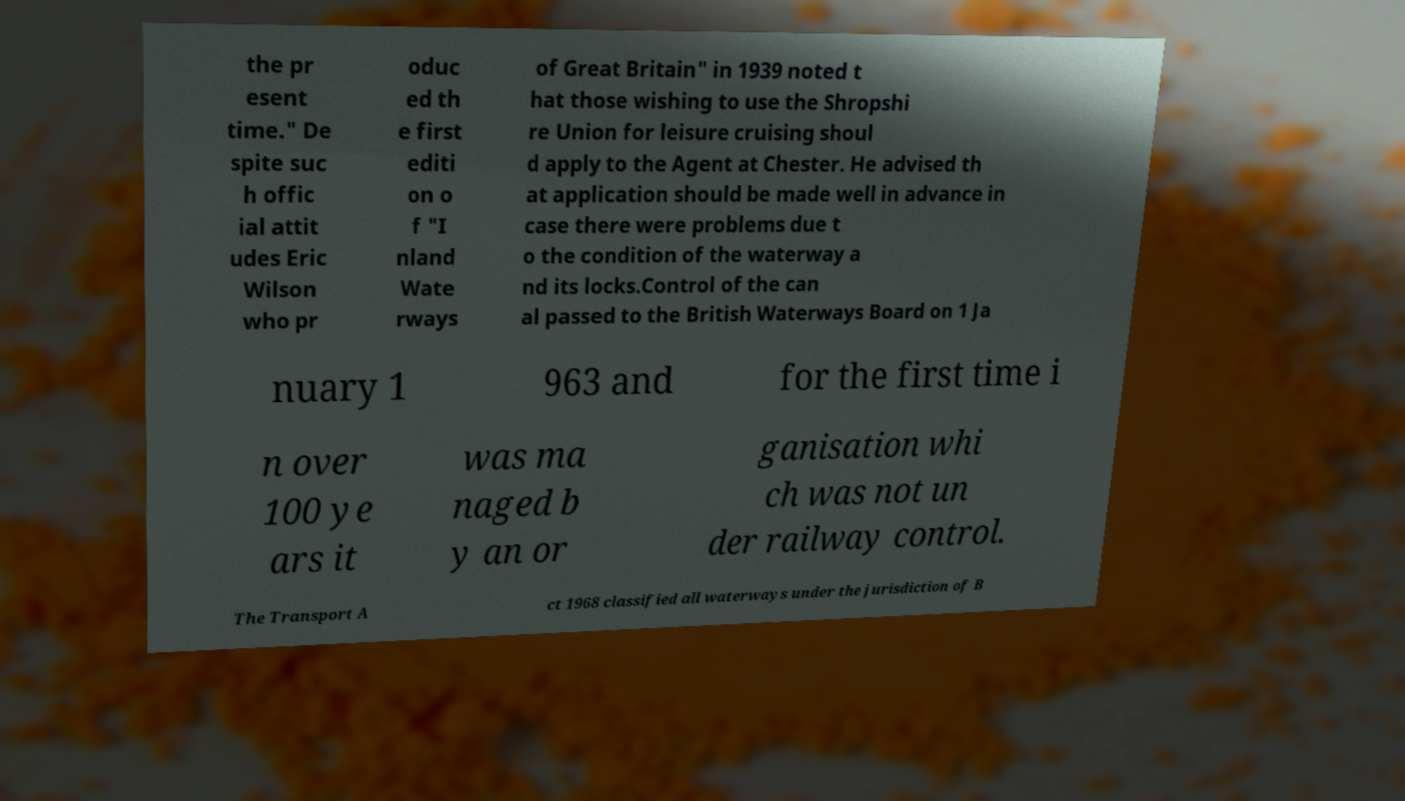For documentation purposes, I need the text within this image transcribed. Could you provide that? the pr esent time." De spite suc h offic ial attit udes Eric Wilson who pr oduc ed th e first editi on o f "I nland Wate rways of Great Britain" in 1939 noted t hat those wishing to use the Shropshi re Union for leisure cruising shoul d apply to the Agent at Chester. He advised th at application should be made well in advance in case there were problems due t o the condition of the waterway a nd its locks.Control of the can al passed to the British Waterways Board on 1 Ja nuary 1 963 and for the first time i n over 100 ye ars it was ma naged b y an or ganisation whi ch was not un der railway control. The Transport A ct 1968 classified all waterways under the jurisdiction of B 